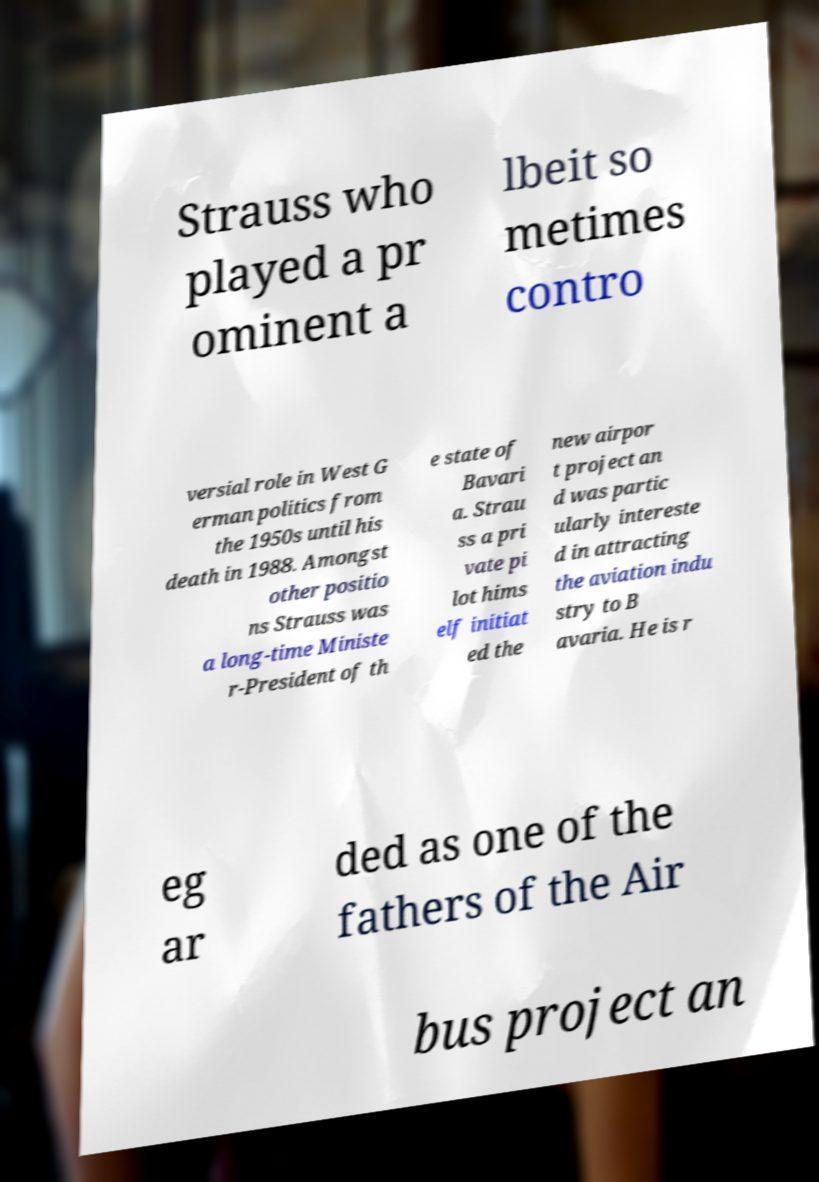What messages or text are displayed in this image? I need them in a readable, typed format. Strauss who played a pr ominent a lbeit so metimes contro versial role in West G erman politics from the 1950s until his death in 1988. Amongst other positio ns Strauss was a long-time Ministe r-President of th e state of Bavari a. Strau ss a pri vate pi lot hims elf initiat ed the new airpor t project an d was partic ularly intereste d in attracting the aviation indu stry to B avaria. He is r eg ar ded as one of the fathers of the Air bus project an 